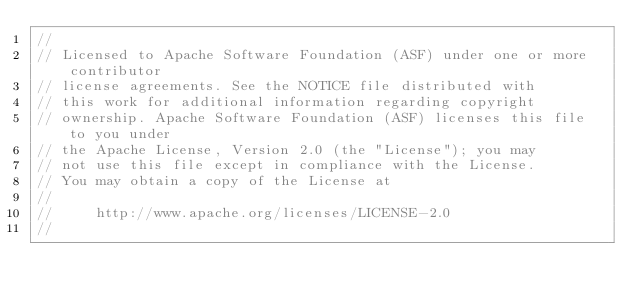<code> <loc_0><loc_0><loc_500><loc_500><_Go_>//
// Licensed to Apache Software Foundation (ASF) under one or more contributor
// license agreements. See the NOTICE file distributed with
// this work for additional information regarding copyright
// ownership. Apache Software Foundation (ASF) licenses this file to you under
// the Apache License, Version 2.0 (the "License"); you may
// not use this file except in compliance with the License.
// You may obtain a copy of the License at
//
//     http://www.apache.org/licenses/LICENSE-2.0
//</code> 